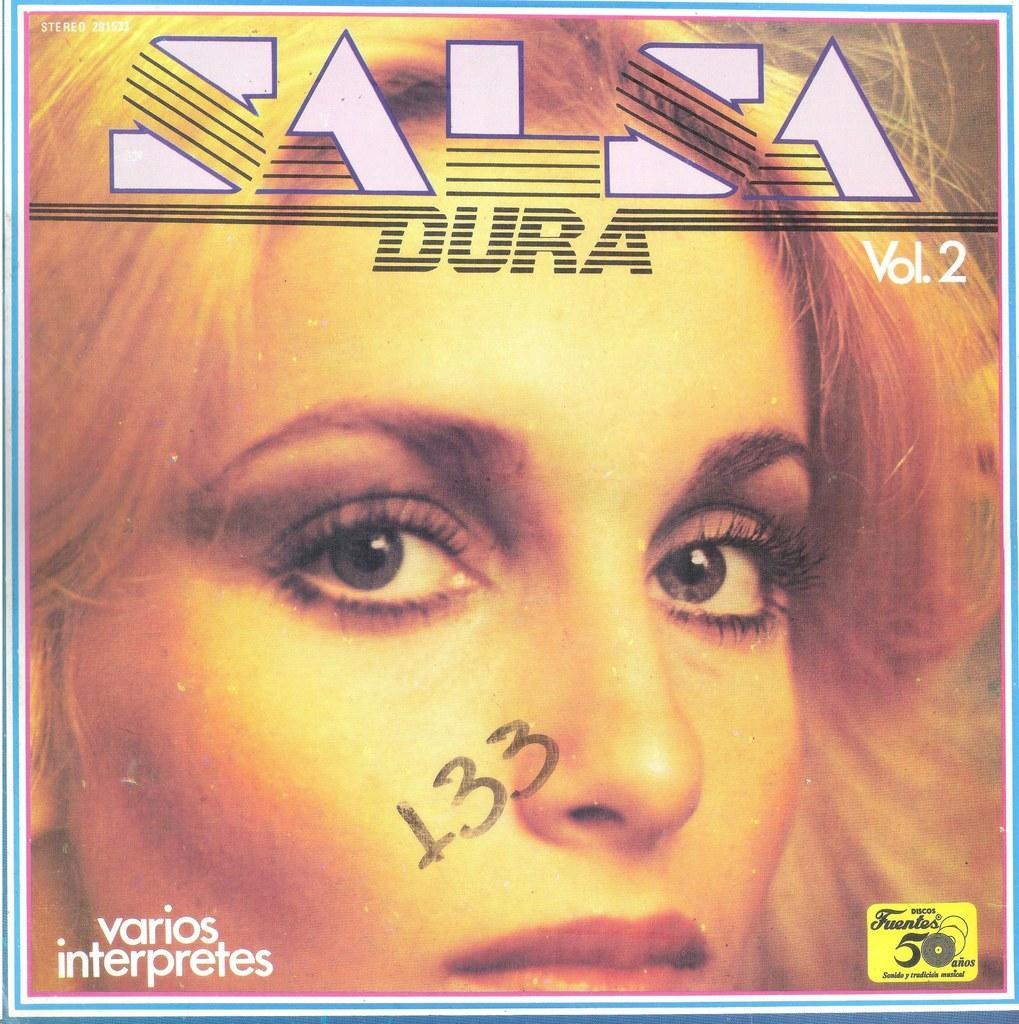<image>
Offer a succinct explanation of the picture presented. A music album cover shows the words Salsa and Dura. 